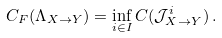<formula> <loc_0><loc_0><loc_500><loc_500>C _ { F } ( \Lambda _ { X \to Y } ) = \inf _ { i \in I } C ( \mathcal { J } ^ { i } _ { X \to Y } ) \, .</formula> 